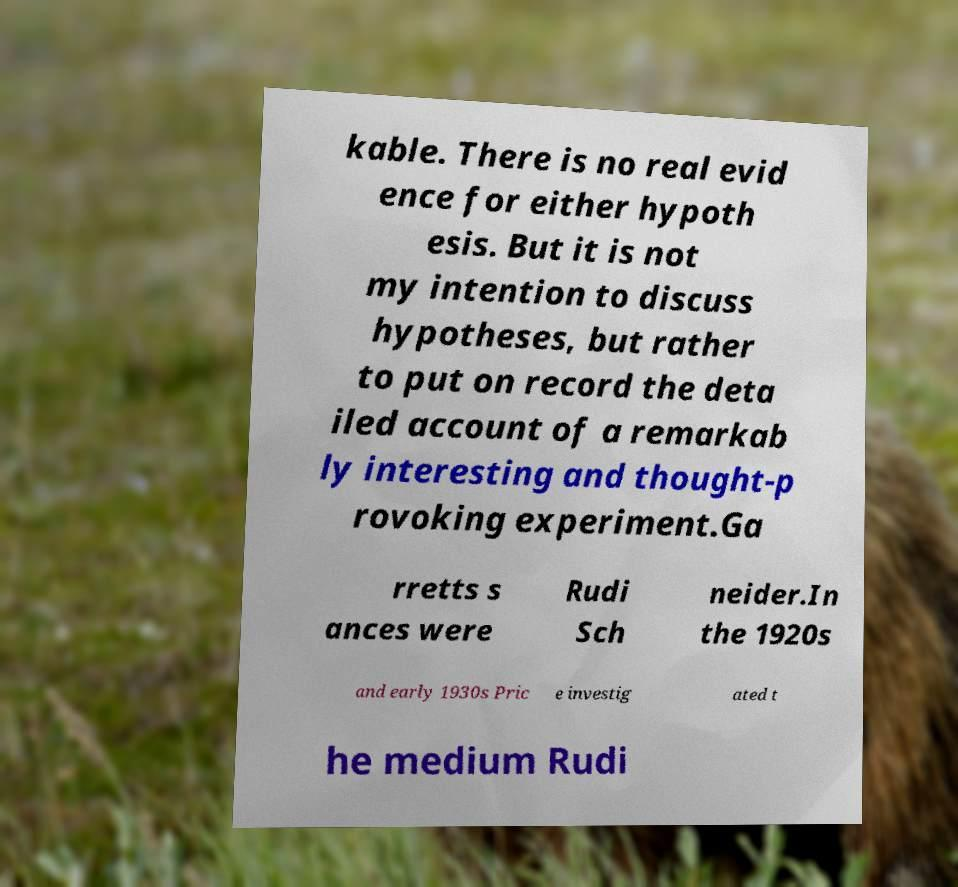Please read and relay the text visible in this image. What does it say? kable. There is no real evid ence for either hypoth esis. But it is not my intention to discuss hypotheses, but rather to put on record the deta iled account of a remarkab ly interesting and thought-p rovoking experiment.Ga rretts s ances were Rudi Sch neider.In the 1920s and early 1930s Pric e investig ated t he medium Rudi 